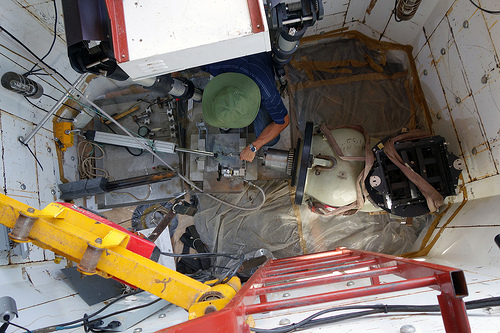<image>
Is the man under the box? Yes. The man is positioned underneath the box, with the box above it in the vertical space. 